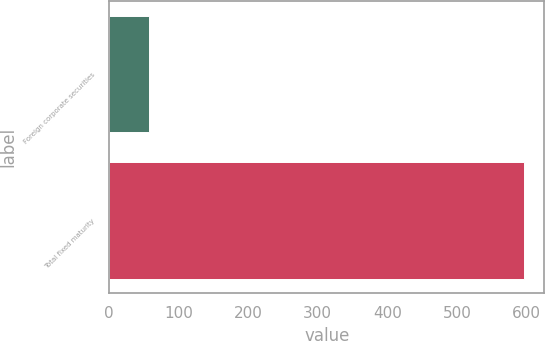<chart> <loc_0><loc_0><loc_500><loc_500><bar_chart><fcel>Foreign corporate securities<fcel>Total fixed maturity<nl><fcel>57<fcel>596<nl></chart> 